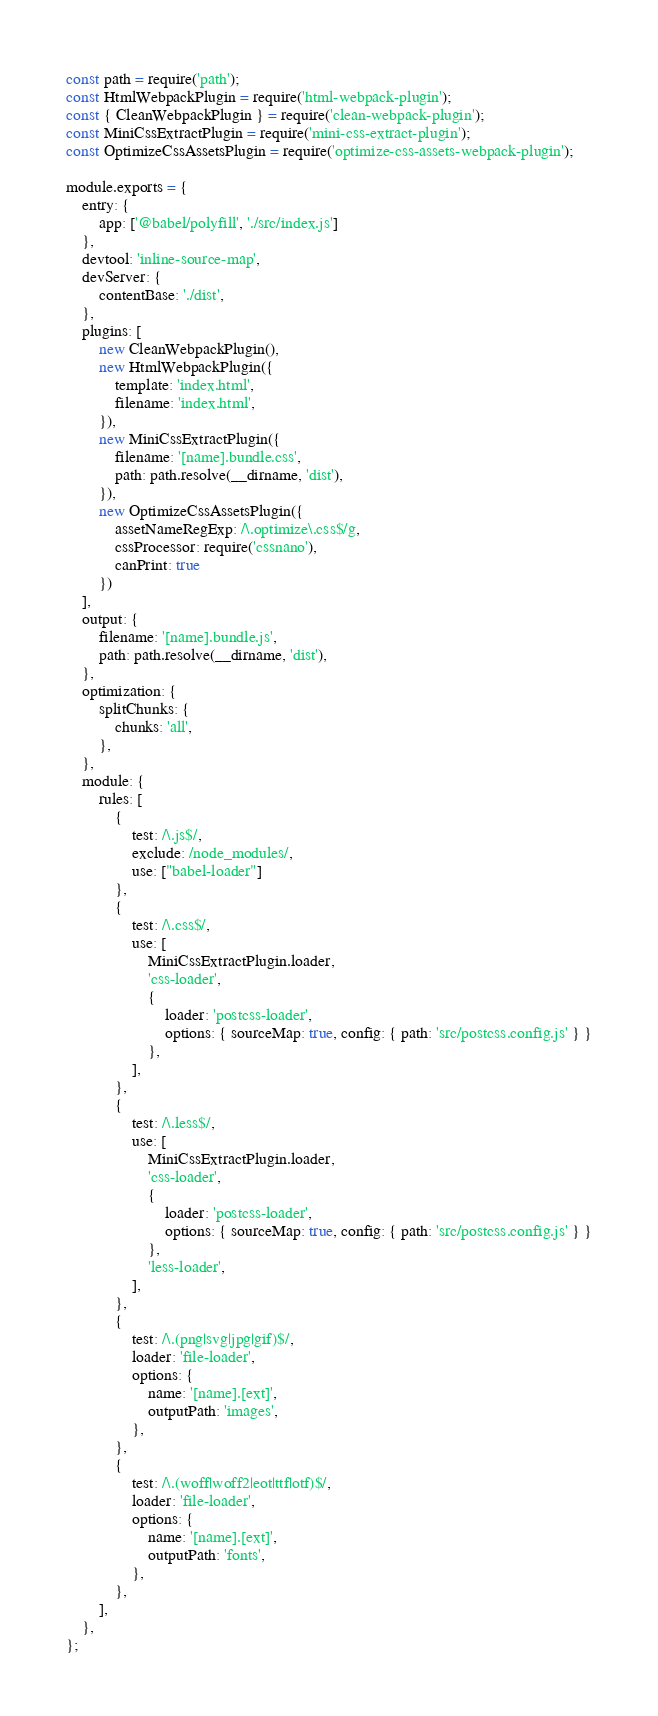Convert code to text. <code><loc_0><loc_0><loc_500><loc_500><_JavaScript_>const path = require('path');
const HtmlWebpackPlugin = require('html-webpack-plugin');
const { CleanWebpackPlugin } = require('clean-webpack-plugin');
const MiniCssExtractPlugin = require('mini-css-extract-plugin');
const OptimizeCssAssetsPlugin = require('optimize-css-assets-webpack-plugin');

module.exports = {
    entry: {
        app: ['@babel/polyfill', './src/index.js']
    },
    devtool: 'inline-source-map',
    devServer: {
        contentBase: './dist',
    },
    plugins: [
        new CleanWebpackPlugin(),
        new HtmlWebpackPlugin({
            template: 'index.html',
            filename: 'index.html',
        }),
        new MiniCssExtractPlugin({
            filename: '[name].bundle.css',
            path: path.resolve(__dirname, 'dist'),
        }),
        new OptimizeCssAssetsPlugin({
            assetNameRegExp: /\.optimize\.css$/g,
            cssProcessor: require('cssnano'),
            canPrint: true
        })
    ],
    output: {
        filename: '[name].bundle.js',
        path: path.resolve(__dirname, 'dist'),
    },
    optimization: {
        splitChunks: {
            chunks: 'all',
        },
    },
    module: {
        rules: [
            {
                test: /\.js$/,
                exclude: /node_modules/,
                use: ["babel-loader"]
            },
            {
                test: /\.css$/,
                use: [
                    MiniCssExtractPlugin.loader,
                    'css-loader',
                    {
                        loader: 'postcss-loader',
                        options: { sourceMap: true, config: { path: 'src/postcss.config.js' } }
                    },
                ],
            },
            {
                test: /\.less$/,
                use: [
                    MiniCssExtractPlugin.loader,
                    'css-loader',
                    {
                        loader: 'postcss-loader',
                        options: { sourceMap: true, config: { path: 'src/postcss.config.js' } }
                    },
                    'less-loader',
                ],
            },
            {
                test: /\.(png|svg|jpg|gif)$/,
                loader: 'file-loader',
                options: {
                    name: '[name].[ext]',
                    outputPath: 'images',
                },
            },
            {
                test: /\.(woff|woff2|eot|ttf|otf)$/,
                loader: 'file-loader',
                options: {
                    name: '[name].[ext]',
                    outputPath: 'fonts',
                },
            },
        ],
    },
};</code> 